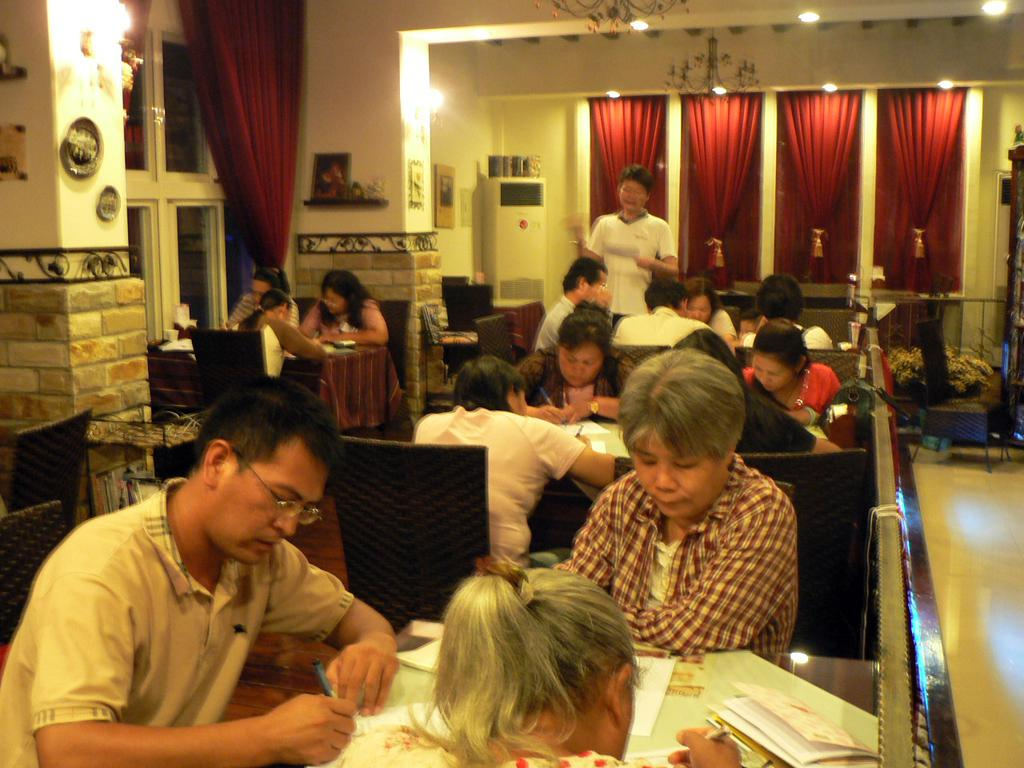What are the people in the image doing? The people in the image are sitting on chairs and writing something. What objects can be seen in the room? There is a cooler, a table, chairs, papers, and a flower vase in the room. What is the color of the background in the room? The background color of the room is red. What type of disease is being discussed by the people in the image? There is no indication in the image that the people are discussing any disease. 